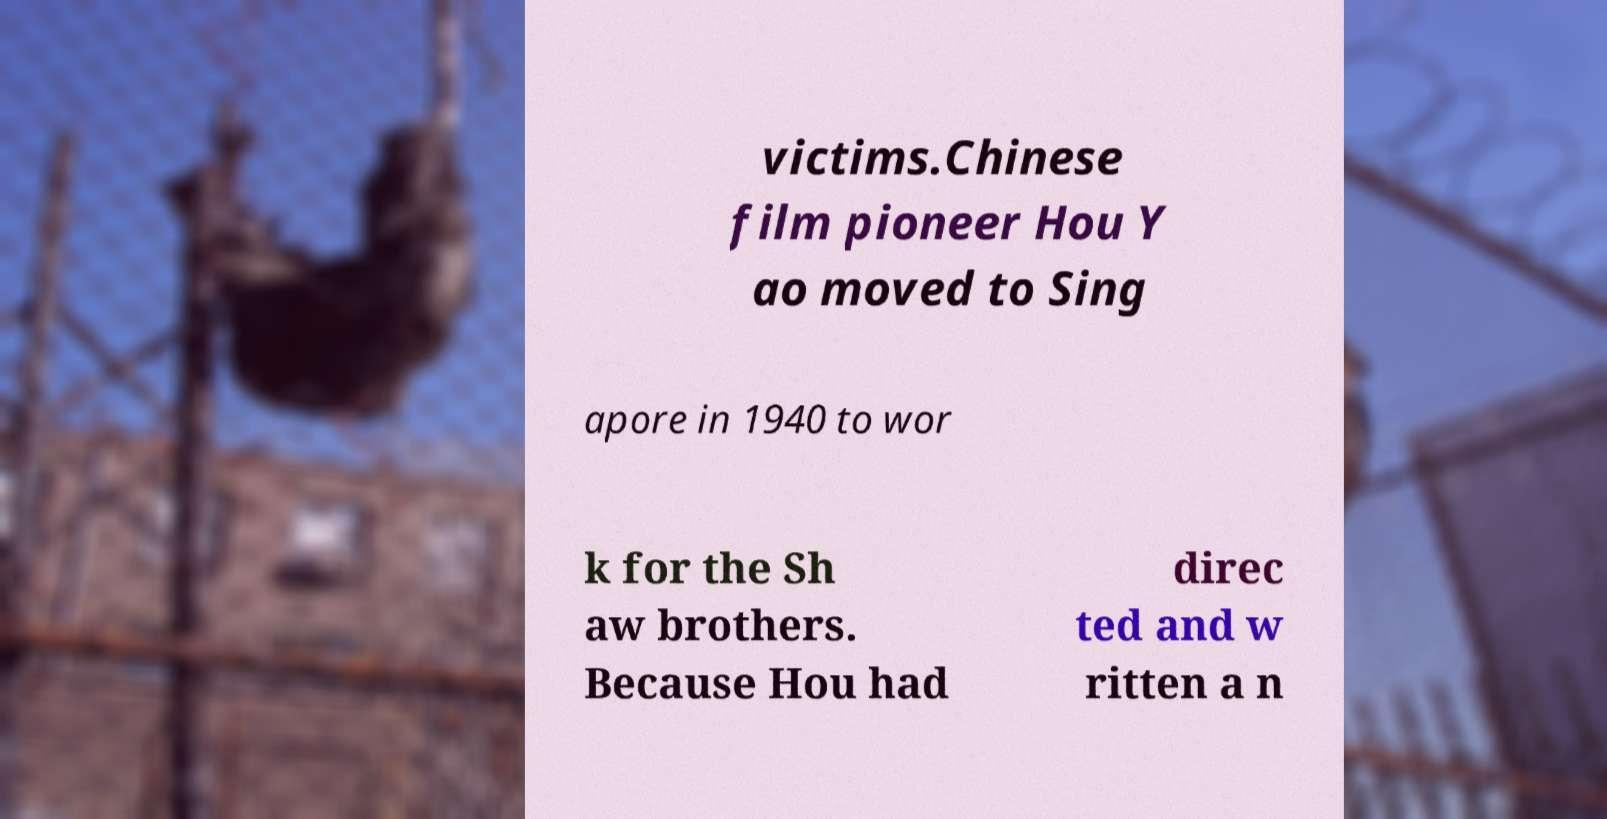I need the written content from this picture converted into text. Can you do that? victims.Chinese film pioneer Hou Y ao moved to Sing apore in 1940 to wor k for the Sh aw brothers. Because Hou had direc ted and w ritten a n 